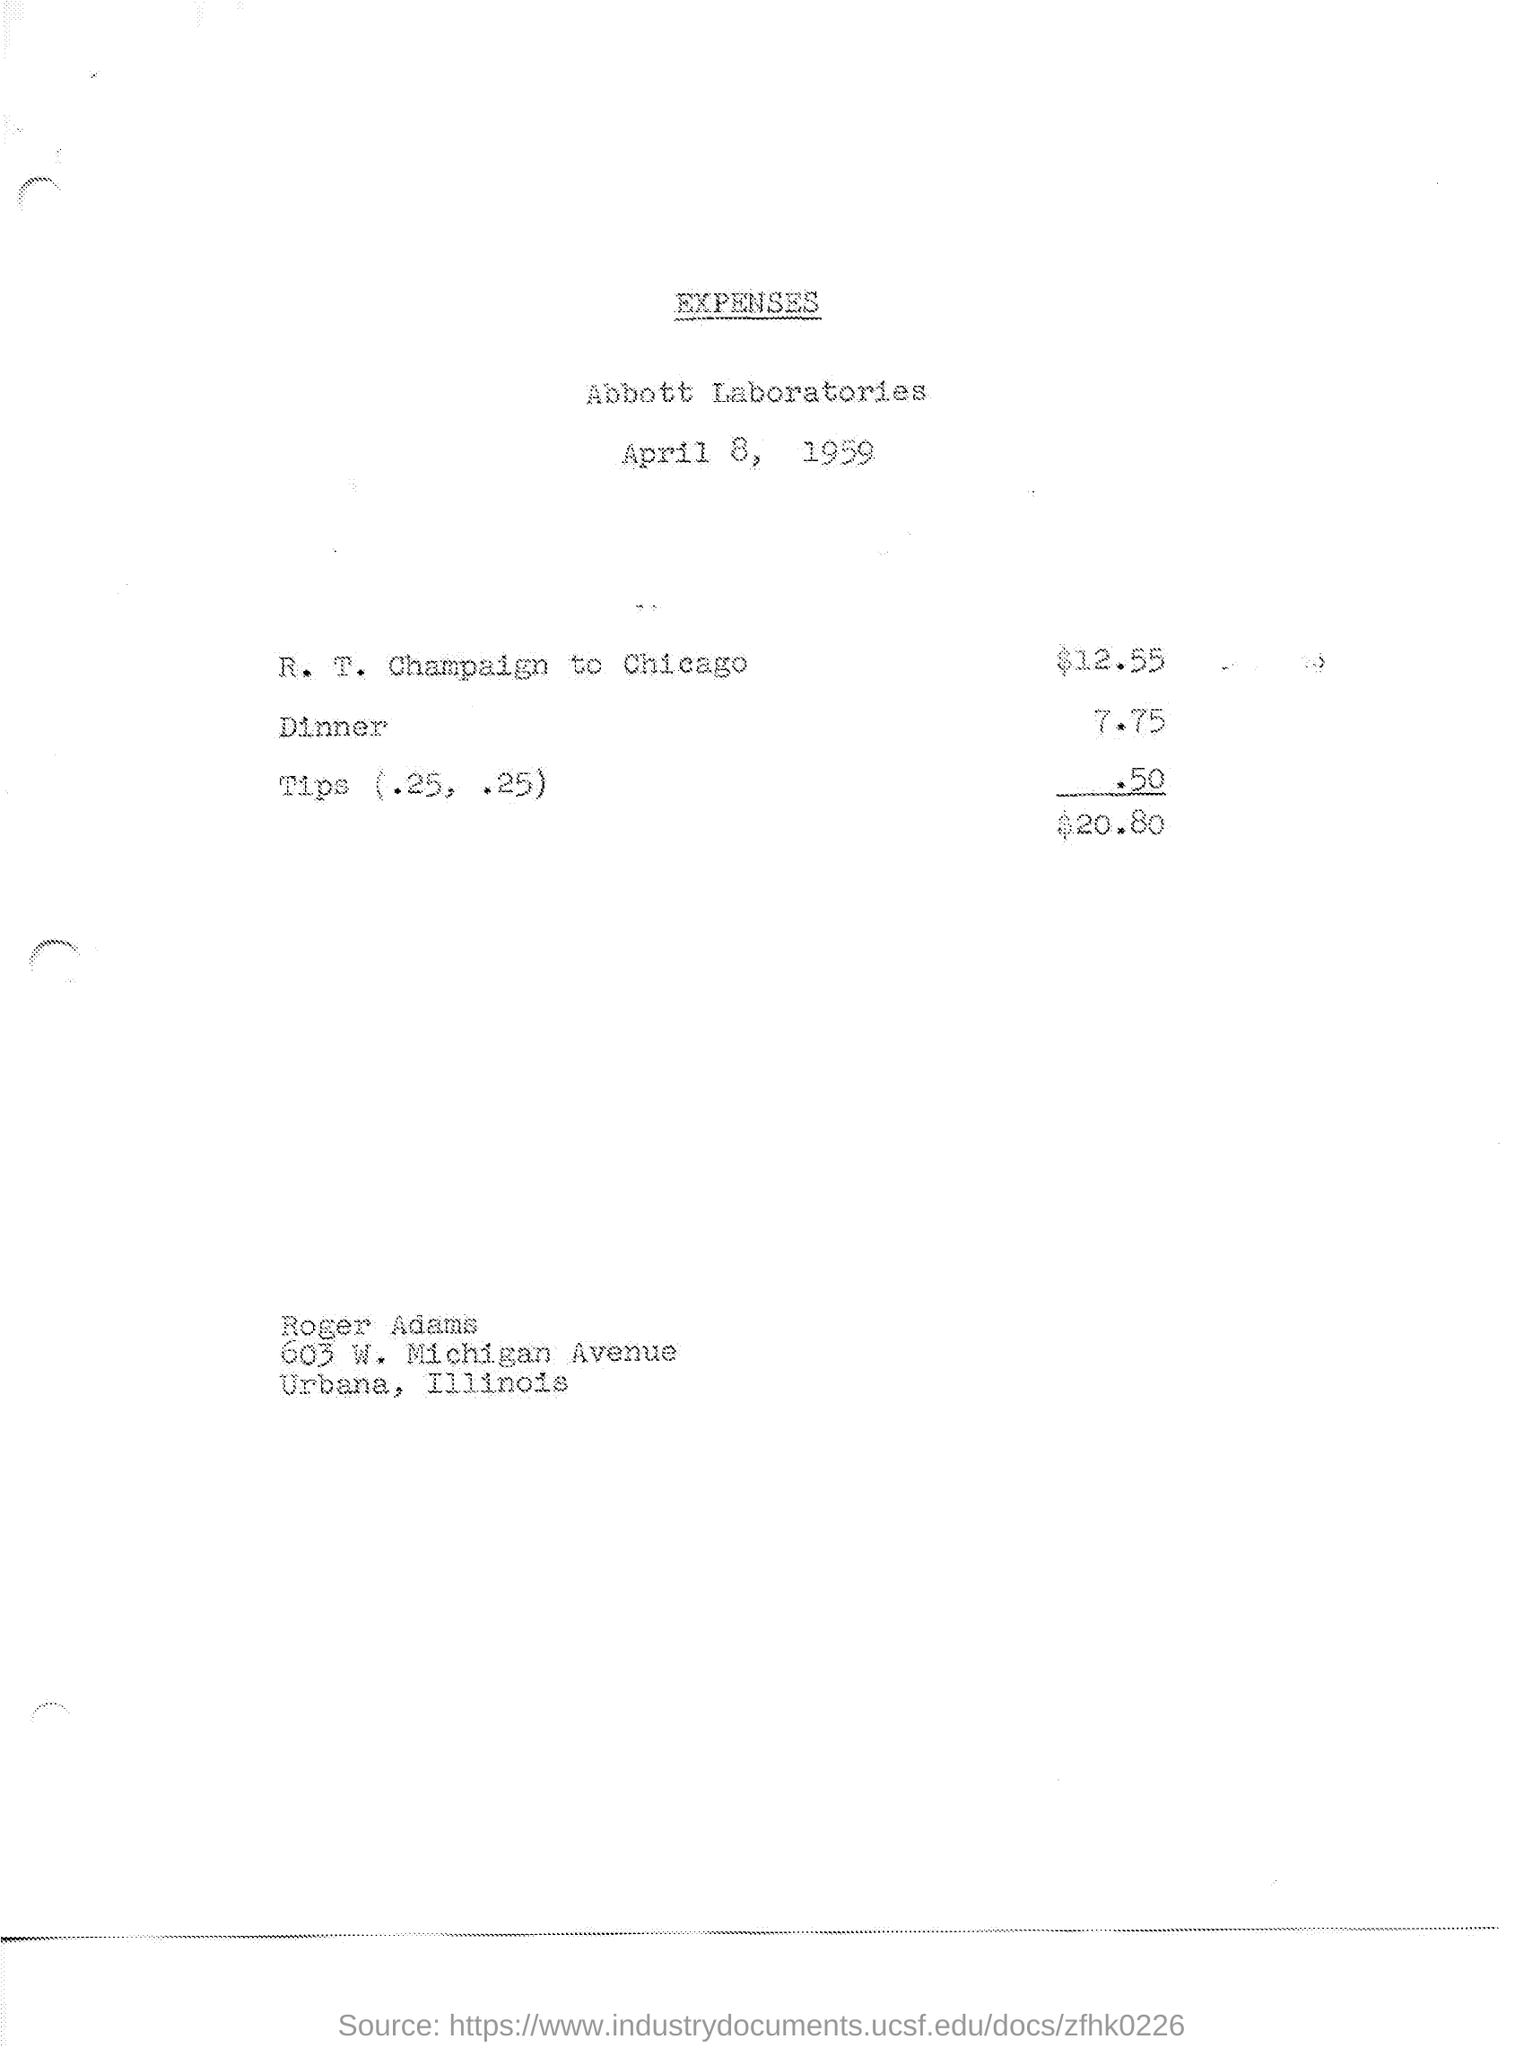What is tips amount? The total amount for tips provided on the expense sheet is $0.50, shown as two separate entries of $0.25 each. 